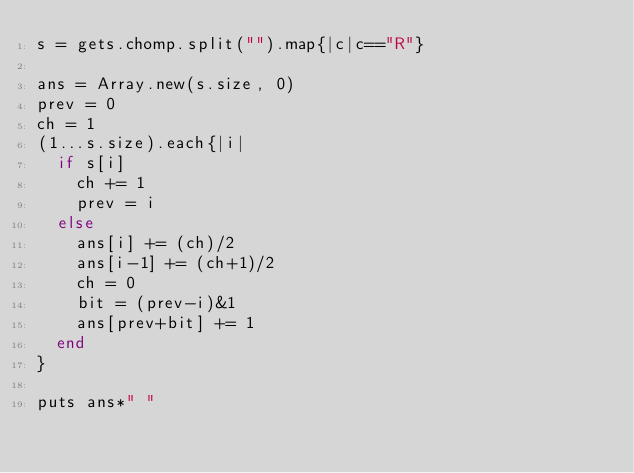Convert code to text. <code><loc_0><loc_0><loc_500><loc_500><_Ruby_>s = gets.chomp.split("").map{|c|c=="R"}

ans = Array.new(s.size, 0)
prev = 0
ch = 1
(1...s.size).each{|i|
  if s[i]
    ch += 1
    prev = i
  else
    ans[i] += (ch)/2
    ans[i-1] += (ch+1)/2
    ch = 0
    bit = (prev-i)&1
    ans[prev+bit] += 1
  end
}

puts ans*" "
</code> 